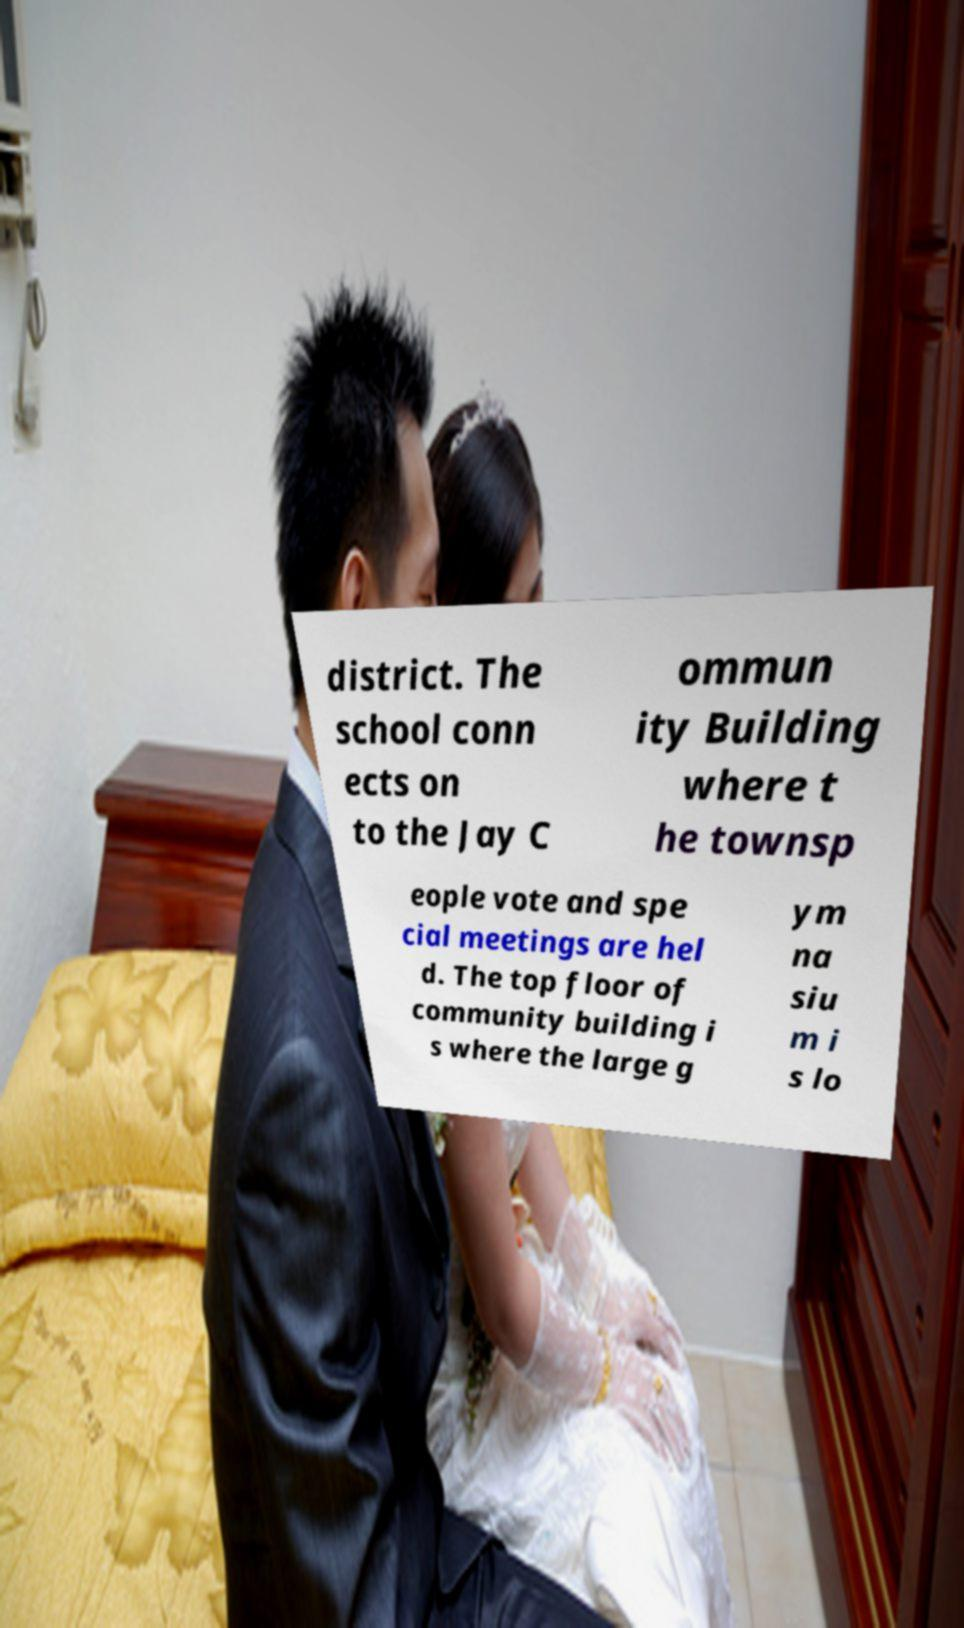Could you extract and type out the text from this image? district. The school conn ects on to the Jay C ommun ity Building where t he townsp eople vote and spe cial meetings are hel d. The top floor of community building i s where the large g ym na siu m i s lo 